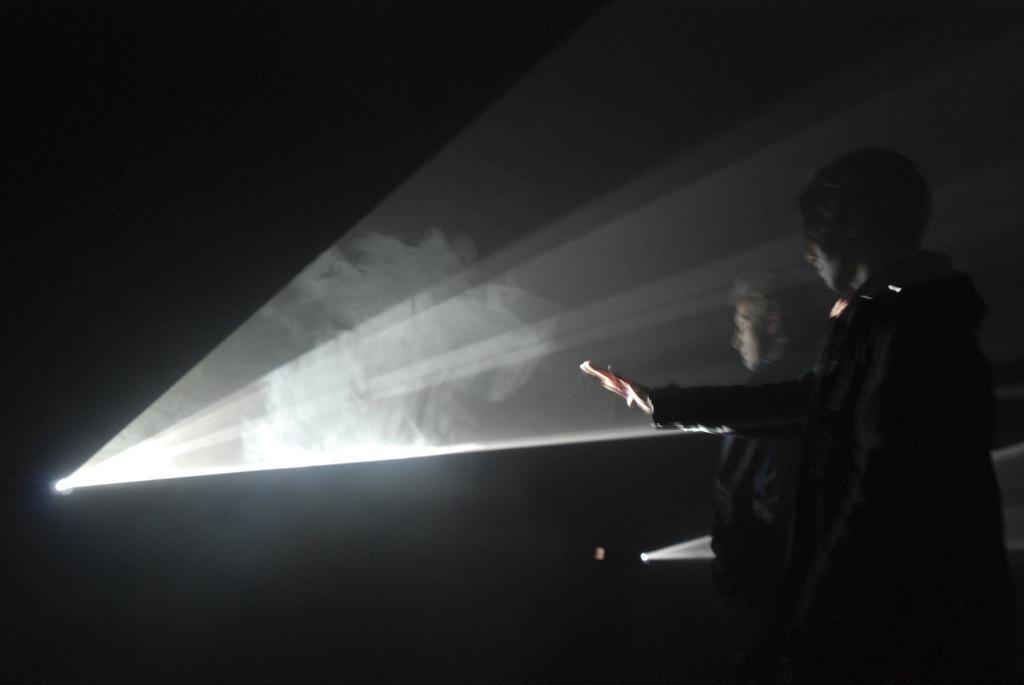Please provide a concise description of this image. In this image I see 2 persons in front and I see the light on the left side of this image and I see that it is dark in the background and I see another light on the bottom of this image. 